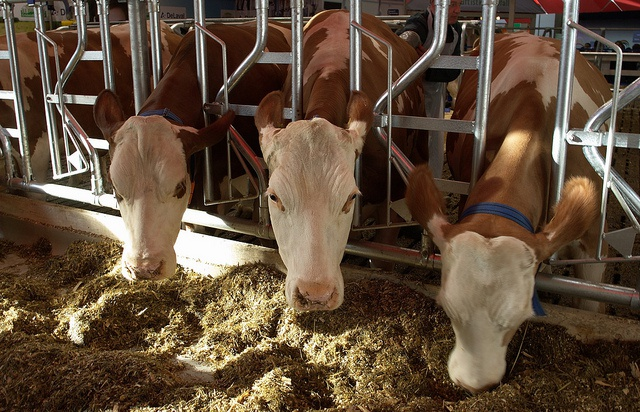Describe the objects in this image and their specific colors. I can see cow in white, maroon, black, and gray tones, cow in white, maroon, gray, tan, and black tones, cow in white, black, gray, maroon, and brown tones, and cow in white, black, maroon, and darkgray tones in this image. 